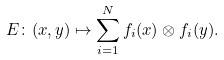<formula> <loc_0><loc_0><loc_500><loc_500>E \colon ( x , y ) \mapsto \sum _ { i = 1 } ^ { N } f _ { i } ( x ) \otimes f _ { i } ( y ) .</formula> 